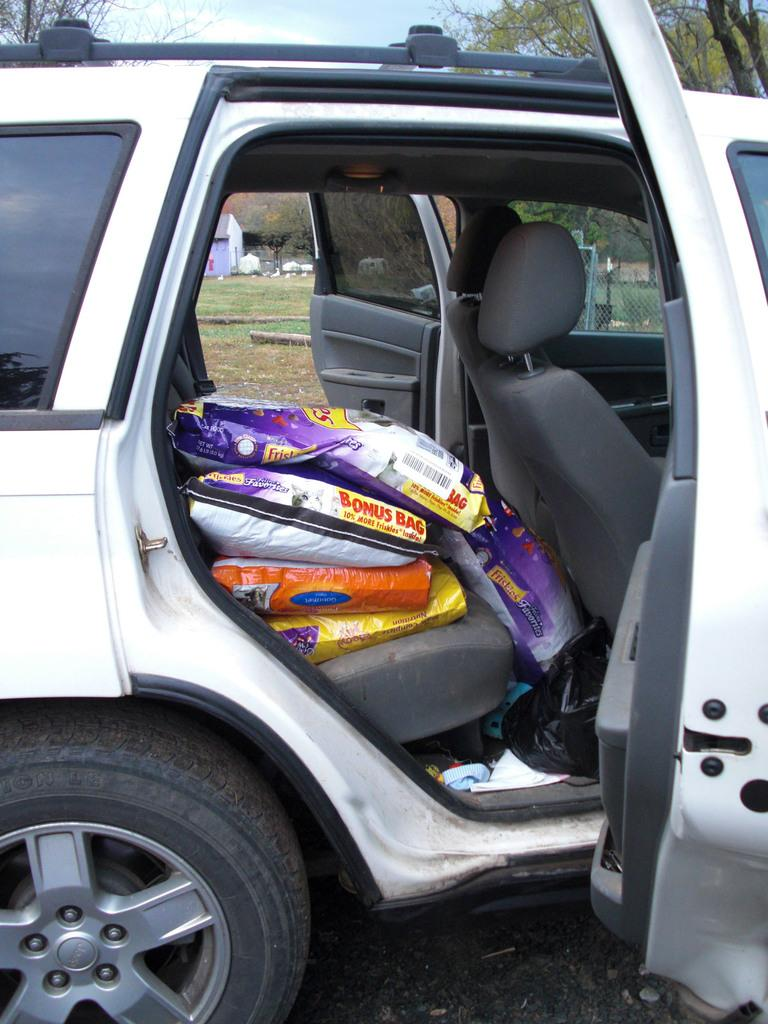What can be found inside the car in the image? There are bags in the car. What is covering something in the car? There is a cover in the car. What type of natural environment is visible in the background of the image? There is grass, trees, and a fence in the background of the image. What is visible in the sky in the background of the image? The sky is visible in the background of the image. What type of structure can be seen in the background of the image? There is a house in the background of the image. What type of twig is being carried by the porter in the image? There is no porter present in the image, and therefore no twig being carried. 